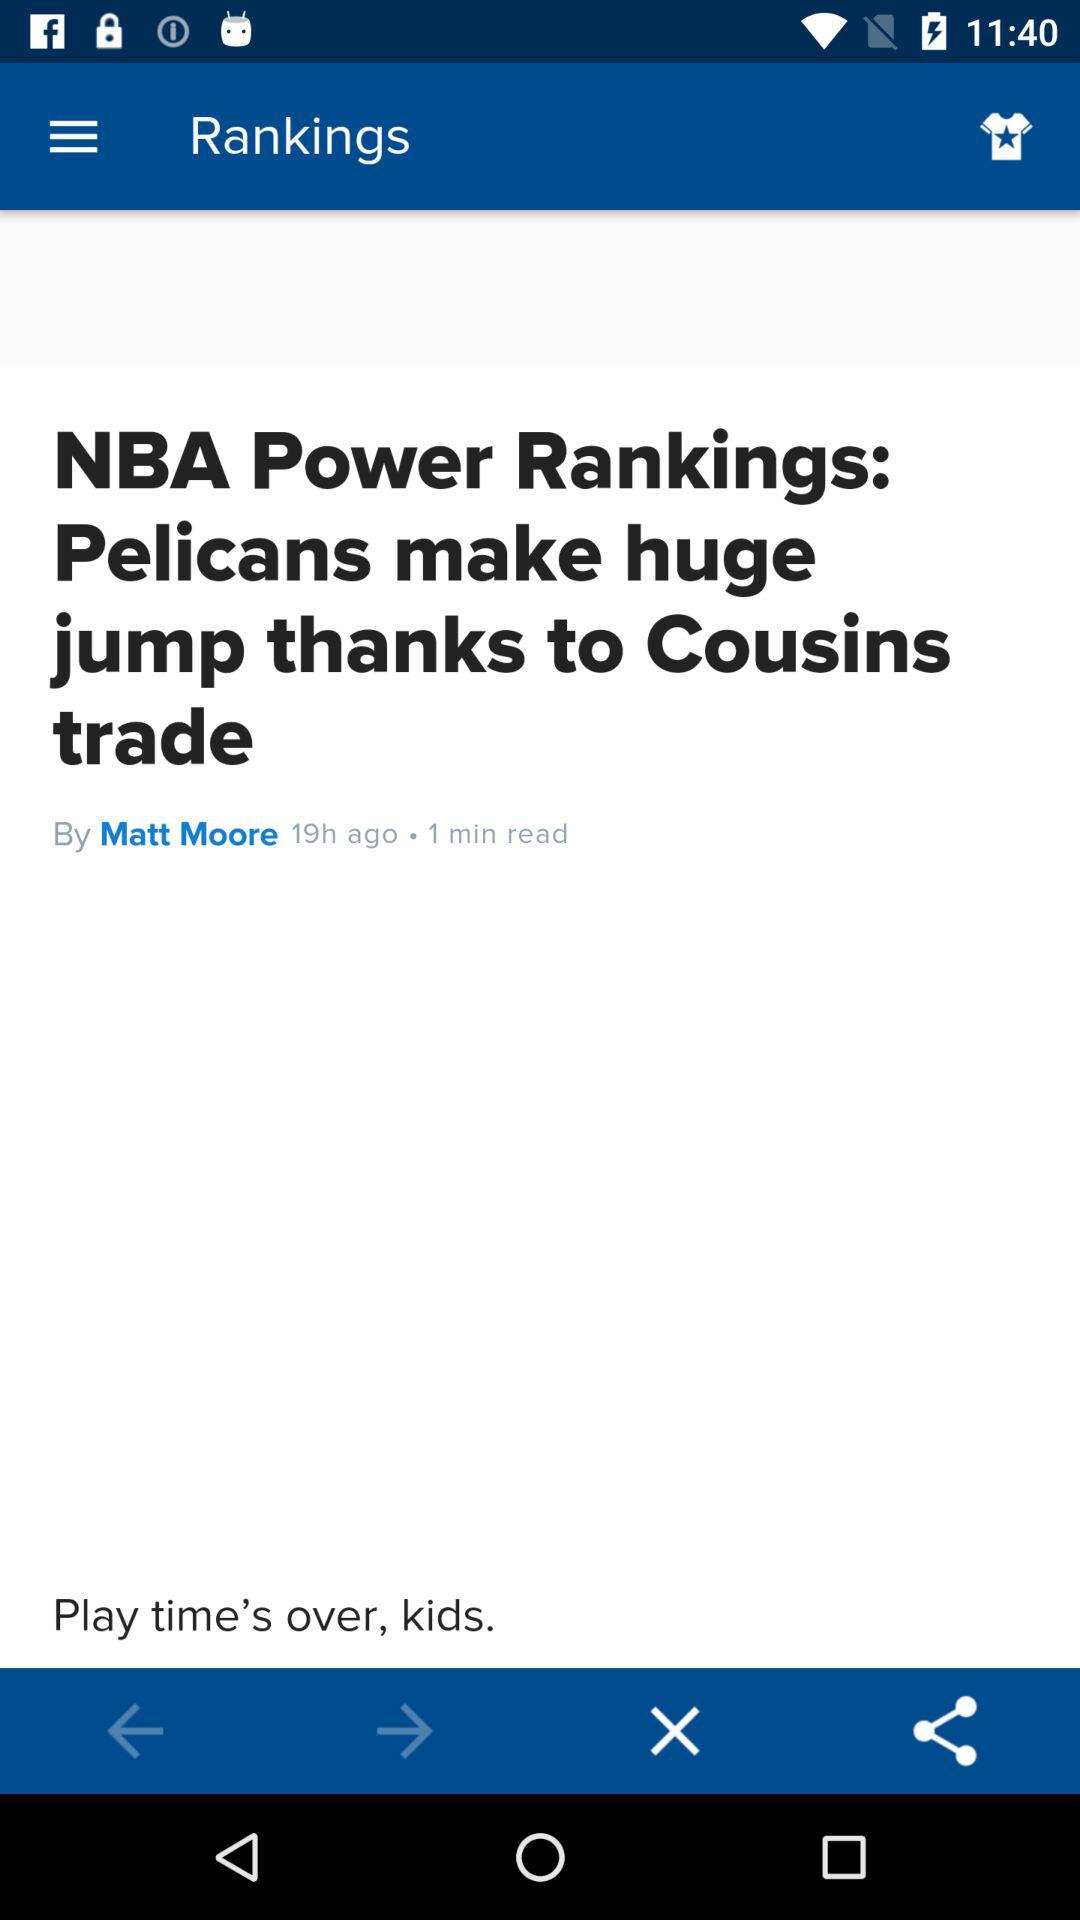What time does the news get posted? The news was posted 19 hours ago. 